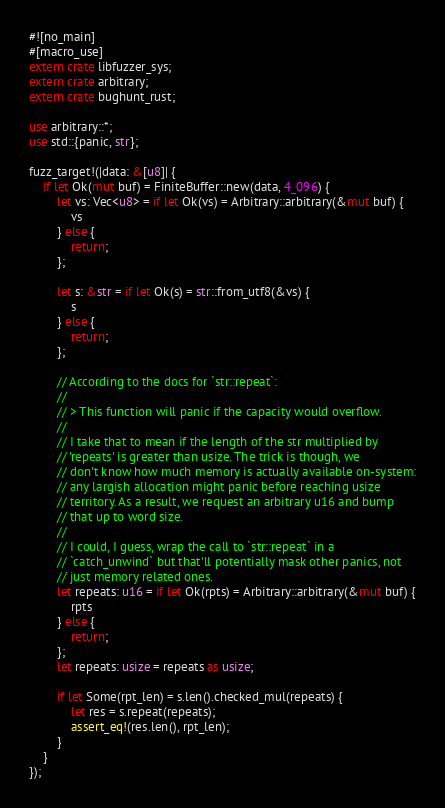<code> <loc_0><loc_0><loc_500><loc_500><_Rust_>#![no_main]
#[macro_use]
extern crate libfuzzer_sys;
extern crate arbitrary;
extern crate bughunt_rust;

use arbitrary::*;
use std::{panic, str};

fuzz_target!(|data: &[u8]| {
    if let Ok(mut buf) = FiniteBuffer::new(data, 4_096) {
        let vs: Vec<u8> = if let Ok(vs) = Arbitrary::arbitrary(&mut buf) {
            vs
        } else {
            return;
        };

        let s: &str = if let Ok(s) = str::from_utf8(&vs) {
            s
        } else {
            return;
        };

        // According to the docs for `str::repeat`:
        //
        // > This function will panic if the capacity would overflow.
        //
        // I take that to mean if the length of the str multiplied by
        // 'repeats' is greater than usize. The trick is though, we
        // don't know how much memory is actually available on-system:
        // any largish allocation might panic before reaching usize
        // territory. As a result, we request an arbitrary u16 and bump
        // that up to word size.
        //
        // I could, I guess, wrap the call to `str::repeat` in a
        // `catch_unwind` but that'll potentially mask other panics, not
        // just memory related ones.
        let repeats: u16 = if let Ok(rpts) = Arbitrary::arbitrary(&mut buf) {
            rpts
        } else {
            return;
        };
        let repeats: usize = repeats as usize;

        if let Some(rpt_len) = s.len().checked_mul(repeats) {
            let res = s.repeat(repeats);
            assert_eq!(res.len(), rpt_len);
        }
    }
});
</code> 